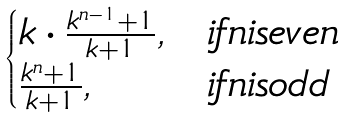<formula> <loc_0><loc_0><loc_500><loc_500>\begin{cases} k \cdot \frac { k ^ { n - 1 } + 1 } { k + 1 } , & i f n i s e v e n \\ \frac { k ^ { n } + 1 } { k + 1 } , & i f n i s o d d \end{cases}</formula> 